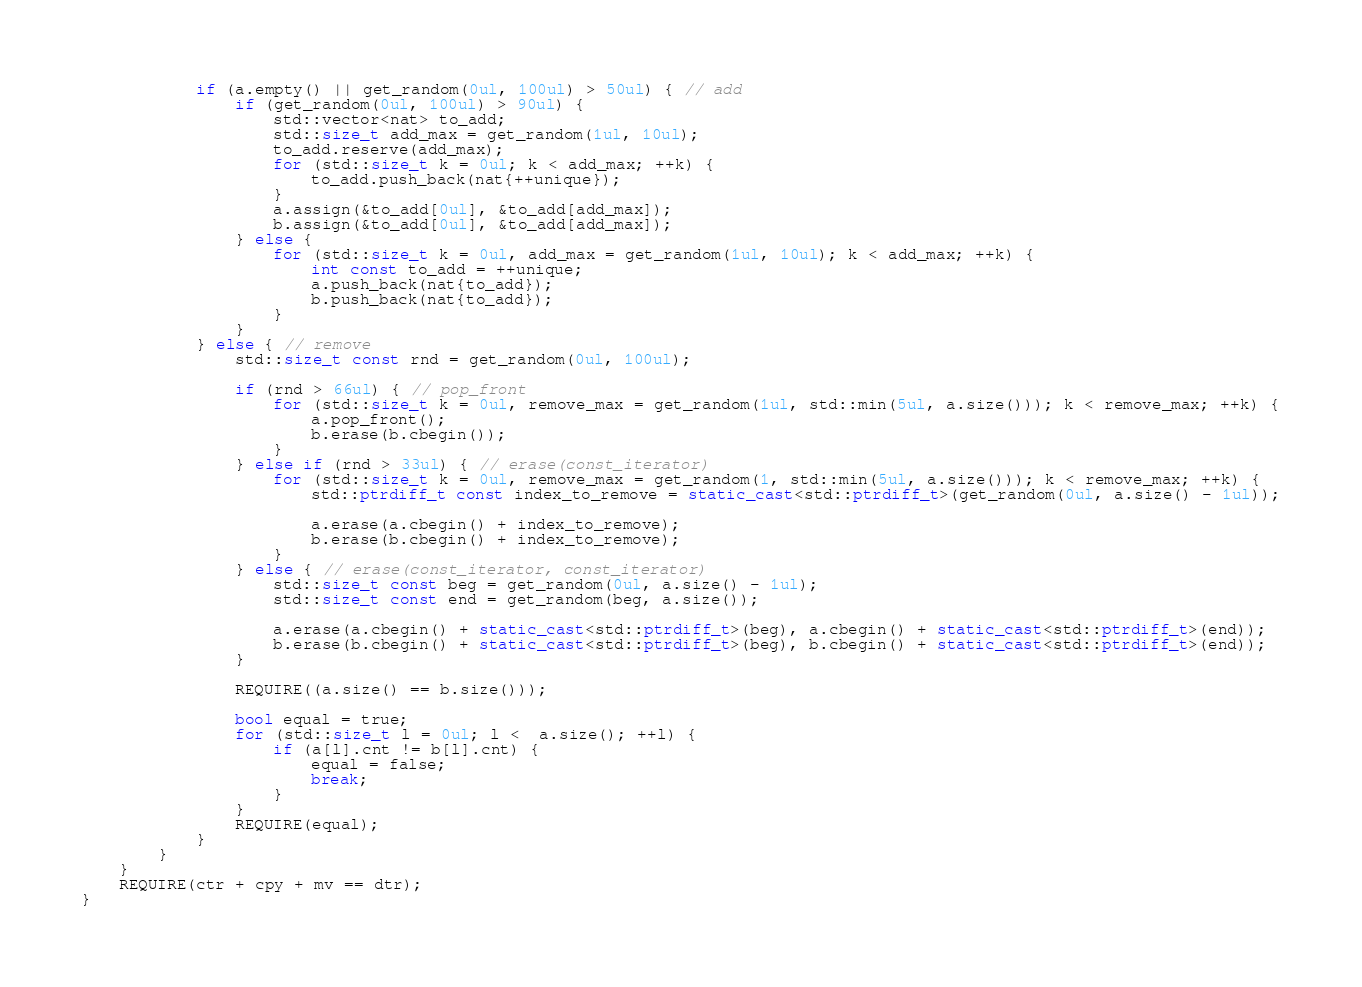Convert code to text. <code><loc_0><loc_0><loc_500><loc_500><_C++_>            if (a.empty() || get_random(0ul, 100ul) > 50ul) { // add
                if (get_random(0ul, 100ul) > 90ul) {
                    std::vector<nat> to_add;
                    std::size_t add_max = get_random(1ul, 10ul);
                    to_add.reserve(add_max);
                    for (std::size_t k = 0ul; k < add_max; ++k) {
                        to_add.push_back(nat{++unique});
                    }
                    a.assign(&to_add[0ul], &to_add[add_max]);
                    b.assign(&to_add[0ul], &to_add[add_max]);
                } else {
                    for (std::size_t k = 0ul, add_max = get_random(1ul, 10ul); k < add_max; ++k) {
                        int const to_add = ++unique;
                        a.push_back(nat{to_add});
                        b.push_back(nat{to_add});
                    }
                }
            } else { // remove
                std::size_t const rnd = get_random(0ul, 100ul);

                if (rnd > 66ul) { // pop_front
                    for (std::size_t k = 0ul, remove_max = get_random(1ul, std::min(5ul, a.size())); k < remove_max; ++k) {
                        a.pop_front();
                        b.erase(b.cbegin());
                    }
                } else if (rnd > 33ul) { // erase(const_iterator)
                    for (std::size_t k = 0ul, remove_max = get_random(1, std::min(5ul, a.size())); k < remove_max; ++k) {
                        std::ptrdiff_t const index_to_remove = static_cast<std::ptrdiff_t>(get_random(0ul, a.size() - 1ul));

                        a.erase(a.cbegin() + index_to_remove);
                        b.erase(b.cbegin() + index_to_remove);
                    }
                } else { // erase(const_iterator, const_iterator)
                    std::size_t const beg = get_random(0ul, a.size() - 1ul);
                    std::size_t const end = get_random(beg, a.size());

                    a.erase(a.cbegin() + static_cast<std::ptrdiff_t>(beg), a.cbegin() + static_cast<std::ptrdiff_t>(end));
                    b.erase(b.cbegin() + static_cast<std::ptrdiff_t>(beg), b.cbegin() + static_cast<std::ptrdiff_t>(end));
                }

                REQUIRE((a.size() == b.size()));

                bool equal = true;
                for (std::size_t l = 0ul; l <  a.size(); ++l) {
                    if (a[l].cnt != b[l].cnt) {
                        equal = false;
                        break;
                    }
                }
                REQUIRE(equal);
            }
        }
    }
    REQUIRE(ctr + cpy + mv == dtr);
}
</code> 